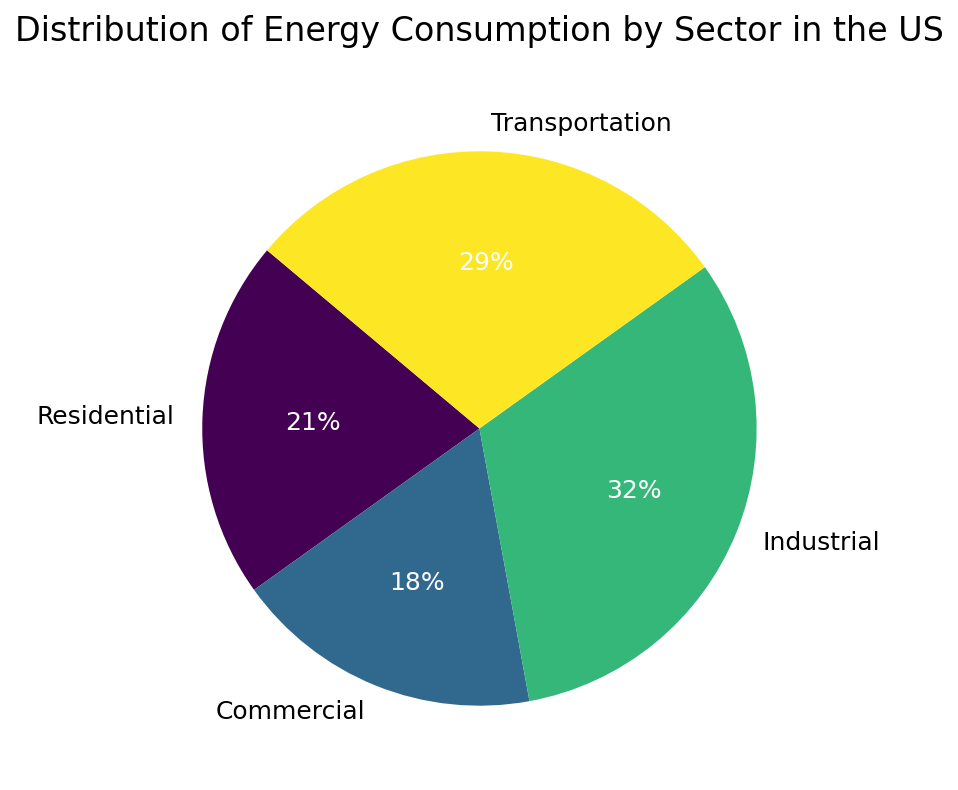what is the sector with the highest energy consumption? The pie chart shows four sectors: Residential, Commercial, Industrial, and Transportation. The sector with the largest wedge in the pie chart represents the highest energy consumption. This wedge is labeled "Industrial."
Answer: Industrial What percentage of energy consumption comes from the Transportation sector? The pie chart indicates that the Transportation sector has a wedge labeled "29%", meaning 29% of the total energy consumption comes from this sector.
Answer: 29% Compare energy consumption in the Residential and Commercial sectors. Which is higher? The pie chart shows that the Residential sector consumes 21% of the energy, while the Commercial sector consumes 18%. Since 21% is greater than 18%, Residential has higher consumption.
Answer: Residential What is the sum of energy consumption percentages for the Industrial and Transportation sectors? The pie chart shows that the Industrial sector consumes 32%, and the Transportation sector consumes 29%. Adding these two percentages together gives 32% + 29% = 61%.
Answer: 61% What proportion of energy consumption do Residential and Commercial sectors contribute together? According to the pie chart, the Residential sector consumes 21%, and the Commercial sector consumes 18%. Their combined consumption is 21% + 18% = 39%.
Answer: 39% Is there a sector that consumes less than 20% of the total energy? The pie chart indicates percentages for each sector: Residential (21%), Commercial (18%), Industrial (32%), and Transportation (29%). Only the Commercial sector consumes less than 20% (18%).
Answer: Commercial What is the difference in energy consumption between the Industrial and Residential sectors? From the pie chart, the Industrial sector consumes 32%, and the Residential sector consumes 21%. The difference is 32% - 21% = 11%.
Answer: 11% If you combine the energy consumption of Residential and Industrial sectors, would they together be more than half of the total energy consumption? The pie chart shows the Residential sector at 21% and the Industrial sector at 32%. Combined, they sum to 21% + 32% = 53%, which is more than half (50%).
Answer: Yes 